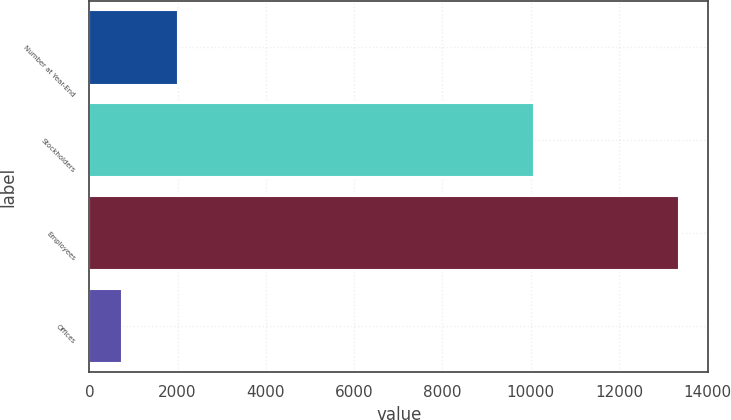<chart> <loc_0><loc_0><loc_500><loc_500><bar_chart><fcel>Number at Year-End<fcel>Stockholders<fcel>Employees<fcel>Offices<nl><fcel>2006<fcel>10084<fcel>13352<fcel>736<nl></chart> 